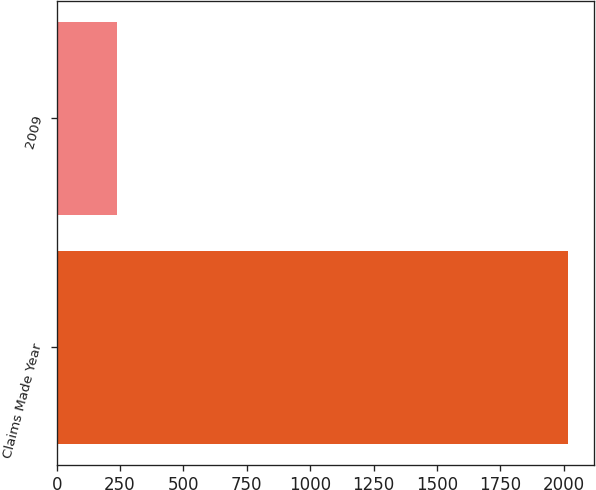Convert chart to OTSL. <chart><loc_0><loc_0><loc_500><loc_500><bar_chart><fcel>Claims Made Year<fcel>2009<nl><fcel>2018<fcel>238<nl></chart> 